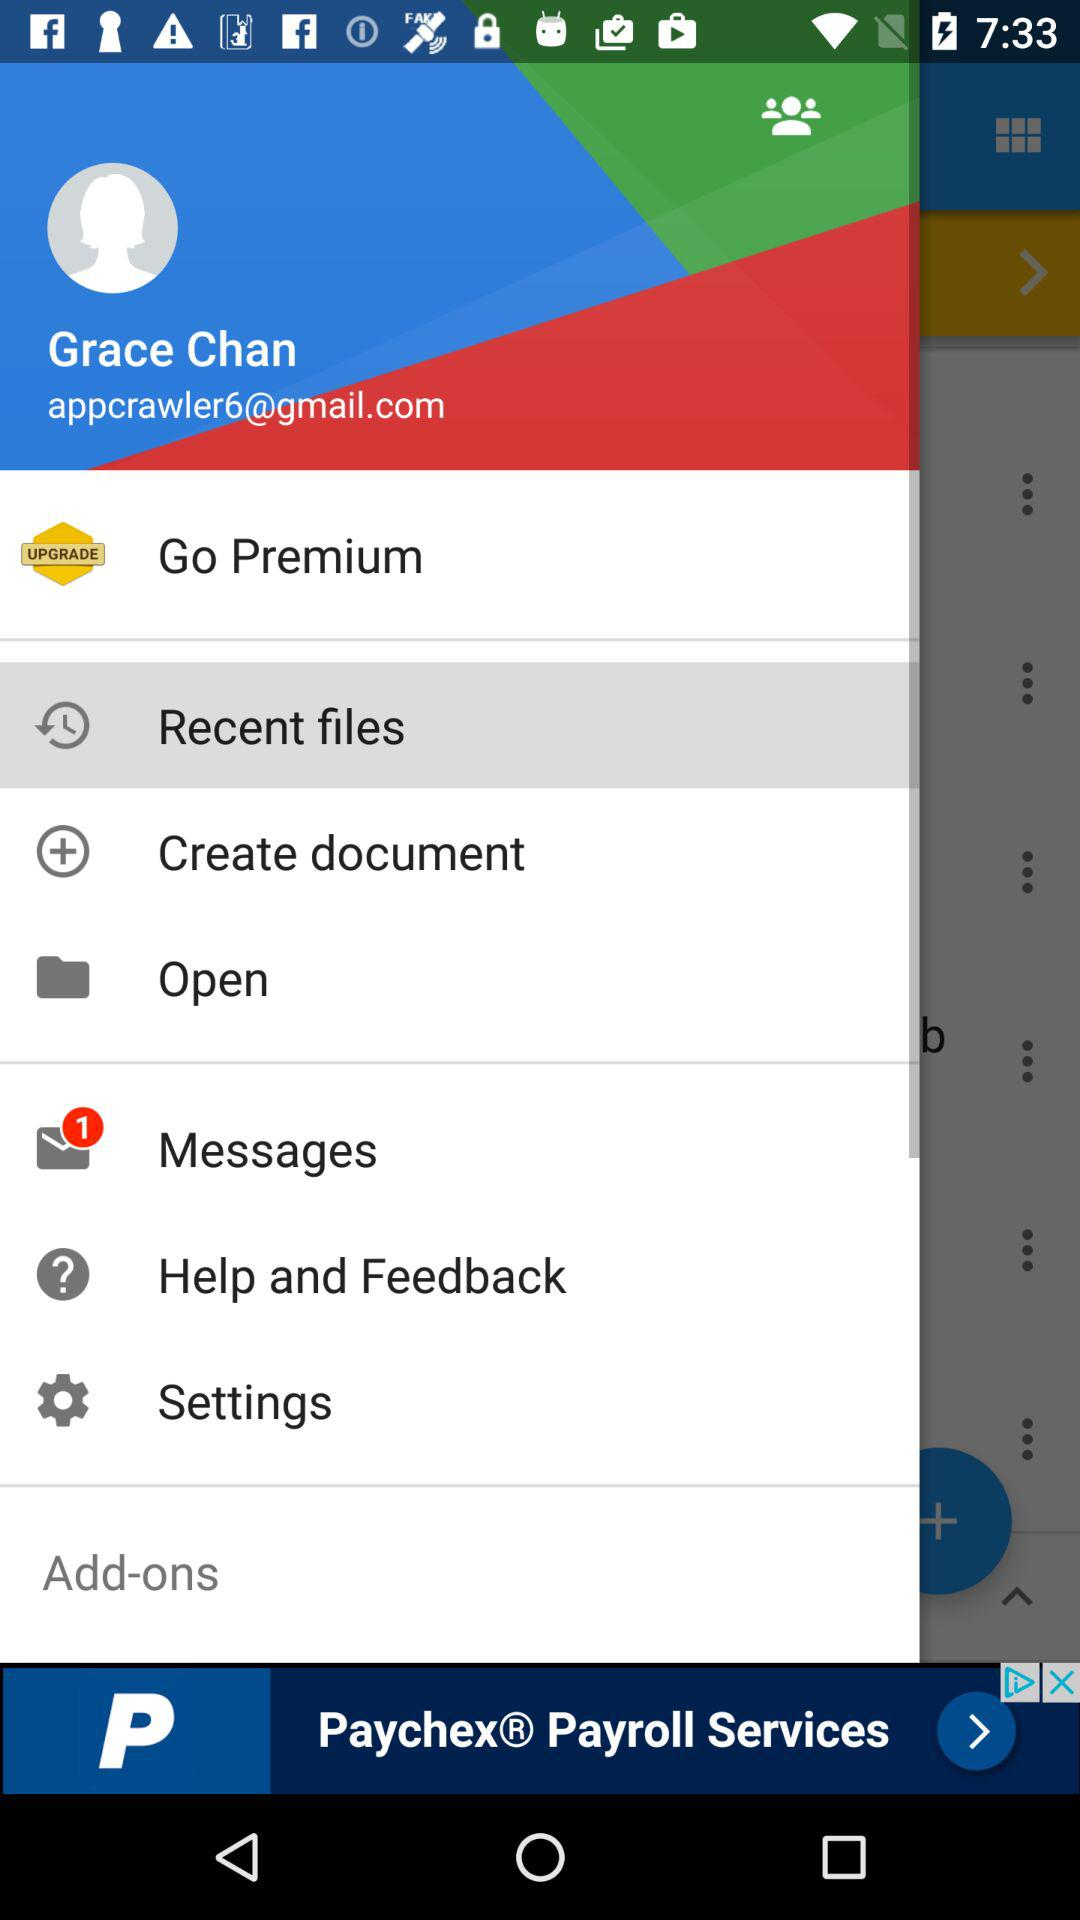What is the email ID of the user? The email ID is appcrawler6@gmail.com. 